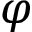<formula> <loc_0><loc_0><loc_500><loc_500>\varphi</formula> 